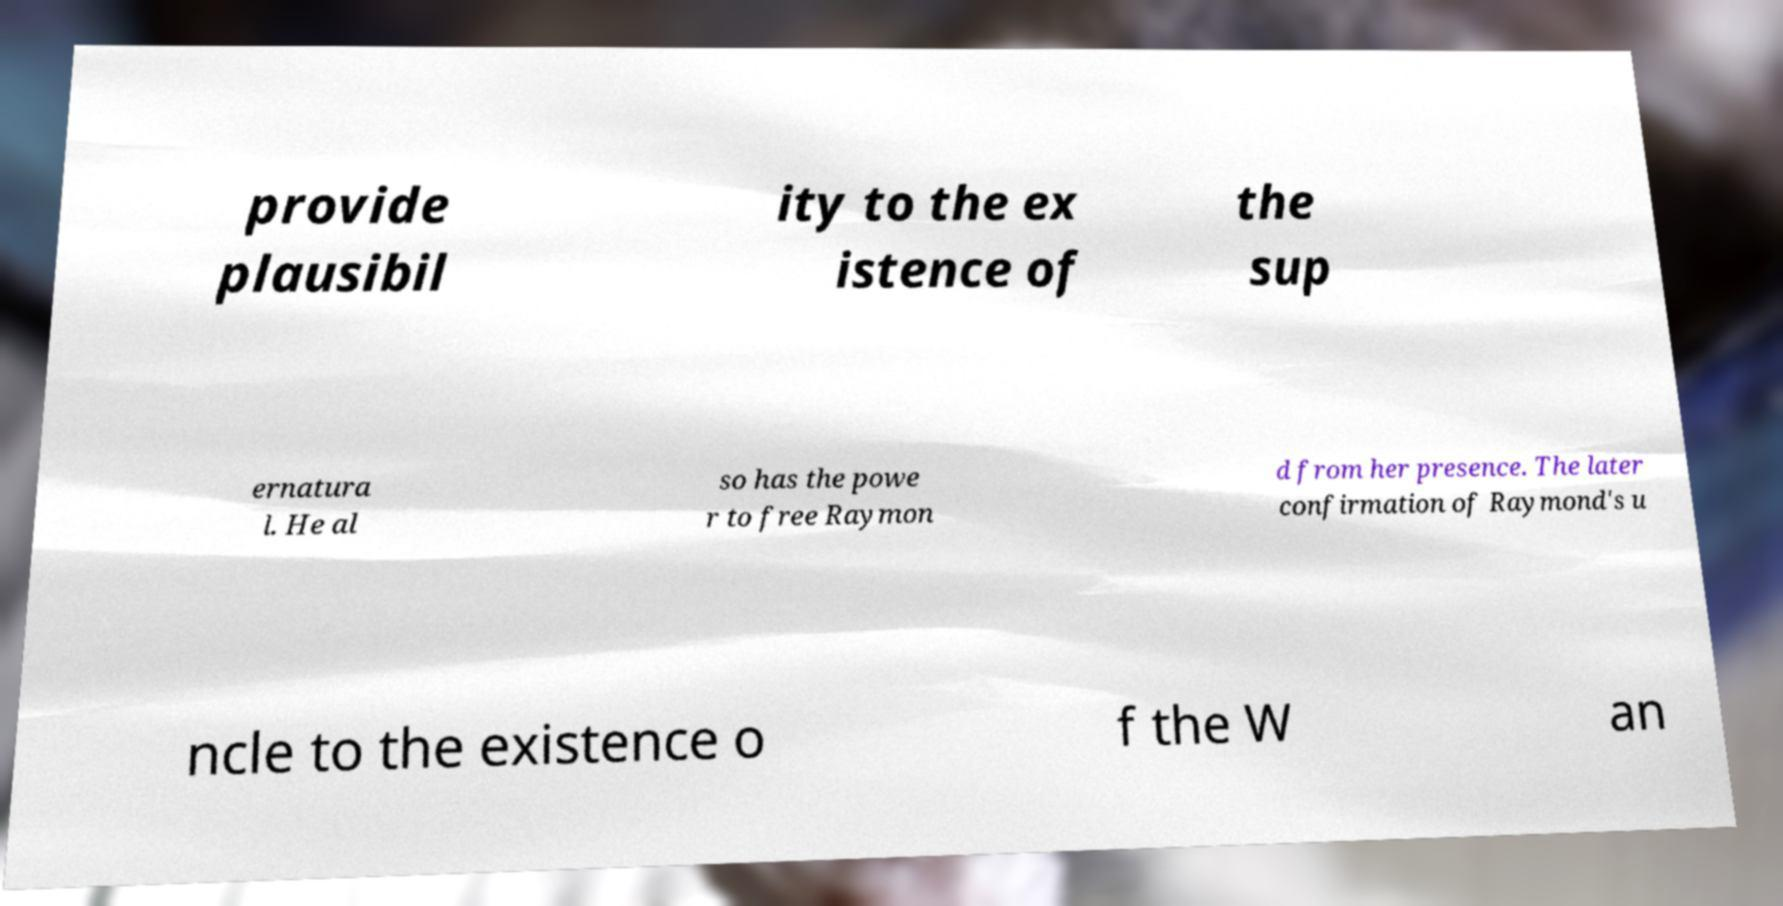Could you extract and type out the text from this image? provide plausibil ity to the ex istence of the sup ernatura l. He al so has the powe r to free Raymon d from her presence. The later confirmation of Raymond's u ncle to the existence o f the W an 